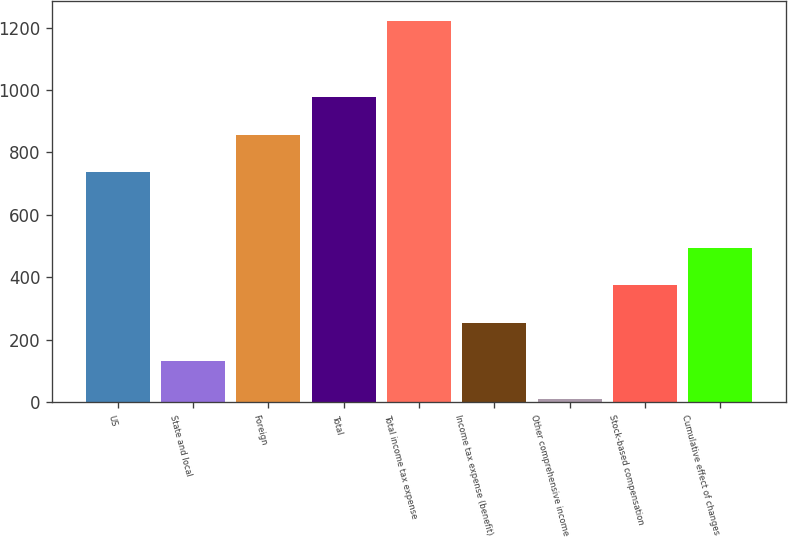Convert chart. <chart><loc_0><loc_0><loc_500><loc_500><bar_chart><fcel>US<fcel>State and local<fcel>Foreign<fcel>Total<fcel>Total income tax expense<fcel>Income tax expense (benefit)<fcel>Other comprehensive income<fcel>Stock-based compensation<fcel>Cumulative effect of changes<nl><fcel>736.4<fcel>131.9<fcel>857.3<fcel>978.2<fcel>1222.9<fcel>252.8<fcel>11<fcel>373.7<fcel>494.6<nl></chart> 